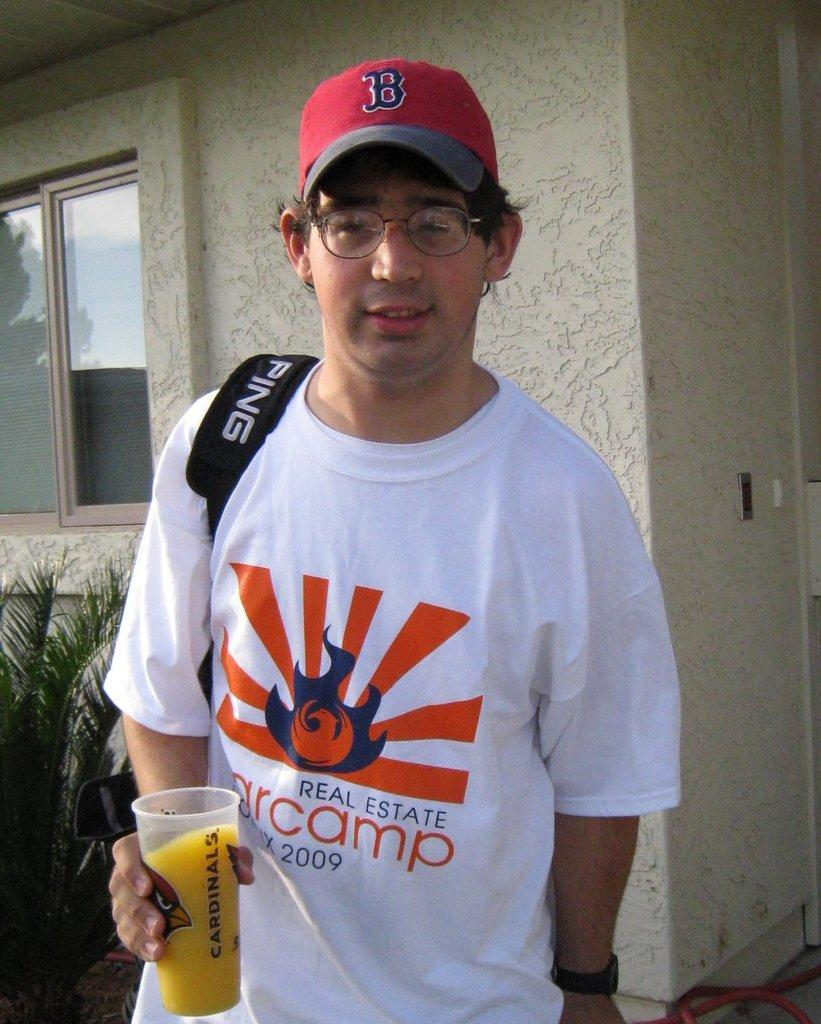Provide a one-sentence caption for the provided image. A man in a white shirt holding a glass of juice with Cardinals written on it. 